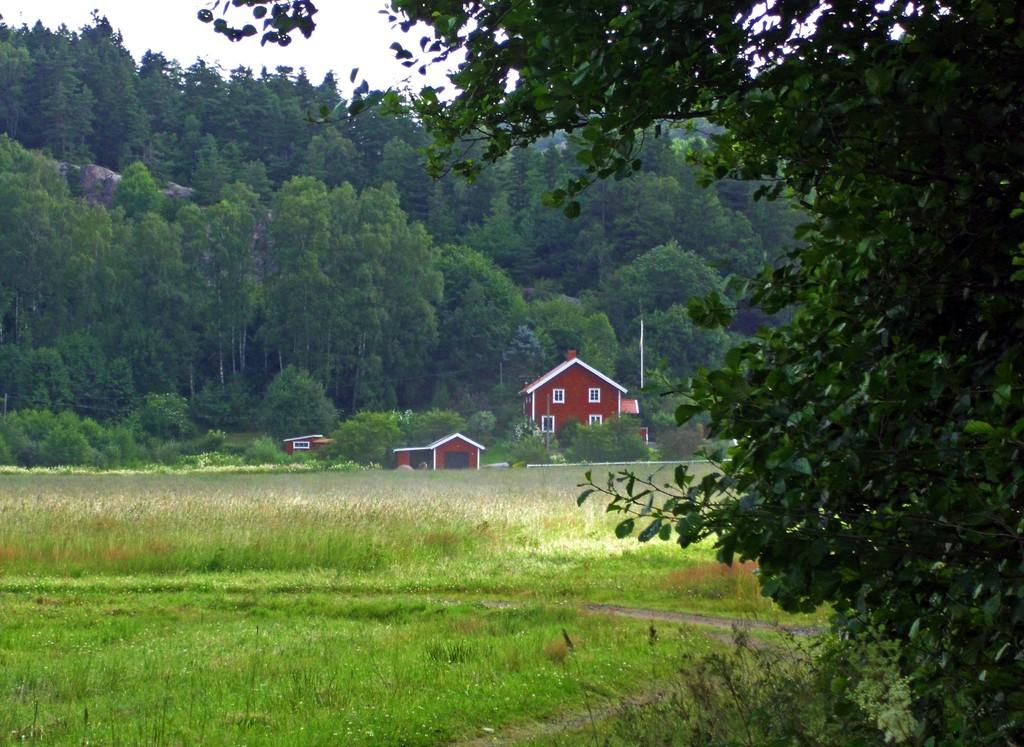What type of structures can be seen in the image? There are buildings in the image. What is the tall, vertical object in the image? There is a pole in the image. What type of natural elements are present in the image? There are trees, rocks, grass, and plants in the image. What part of the natural environment is visible in the image? The sky is visible in the image. What type of rod can be seen in the image? There is no rod present in the image. What thought is being expressed by the plants in the image? Plants do not have the ability to express thoughts, so this cannot be determined from the image. 